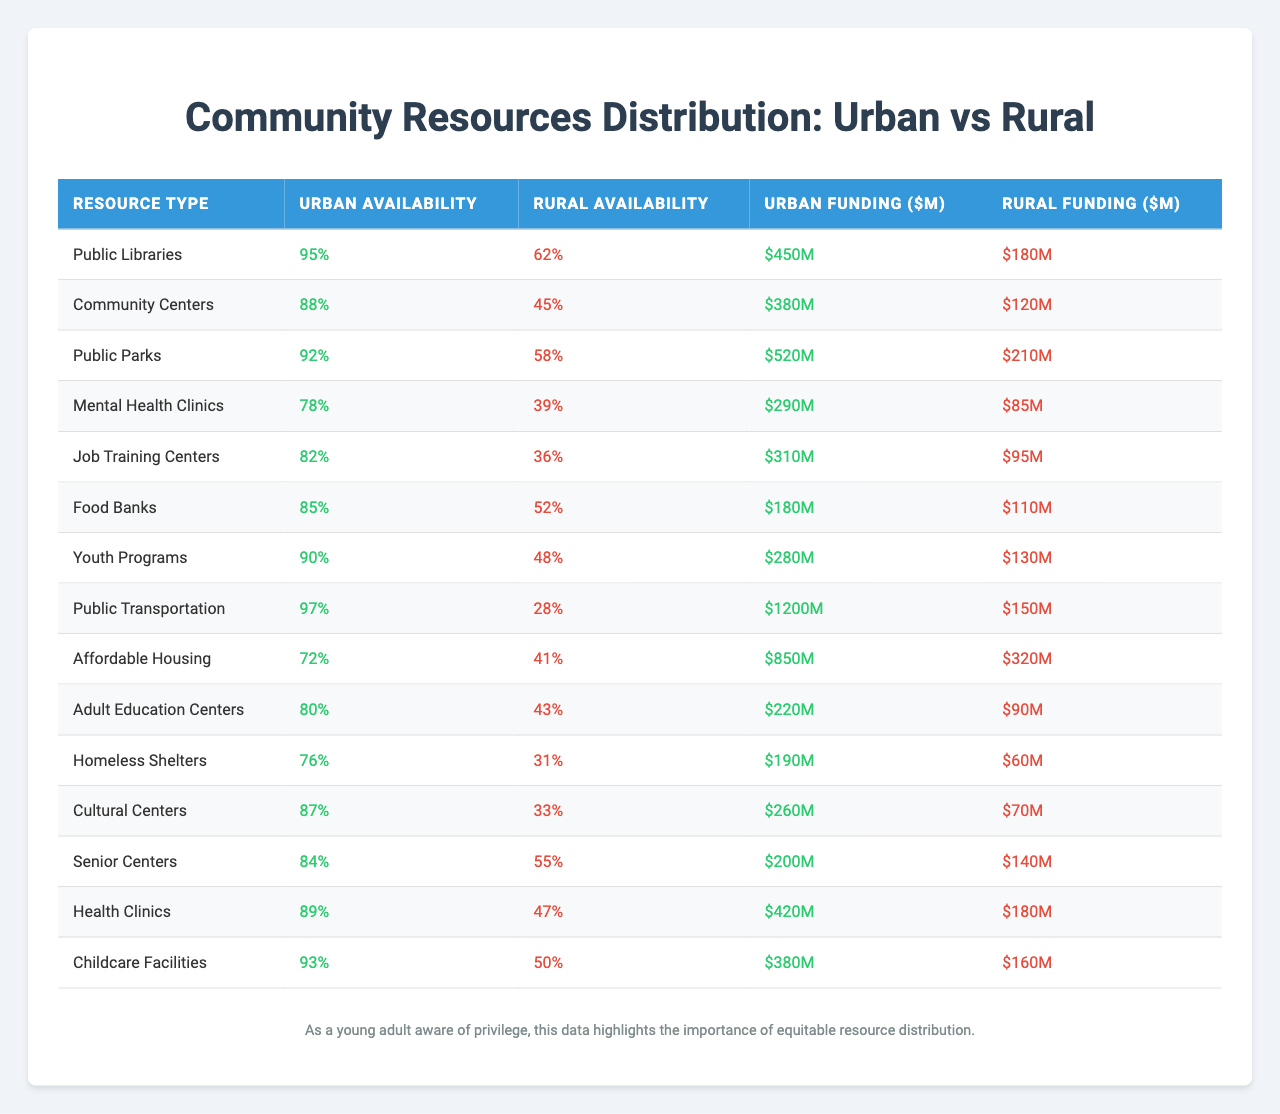What is the Urban Availability percentage for Public Libraries? The table shows that the Urban Availability for Public Libraries is listed as 95%.
Answer: 95% What is the total funding for Rural Food Banks and Mental Health Clinics? The funding for Rural Food Banks is $110M and for Mental Health Clinics is $85M. Adding these together: 110 + 85 = 195
Answer: $195M Are there more public parks in urban or rural areas? The table indicates 92% availability of public parks in urban areas compared to 58% in rural areas.
Answer: Urban areas Which resource type has the highest funding in urban areas? Looking at the table, Public Transportation has the highest funding at $1200M in urban areas.
Answer: Public Transportation What is the difference in Urban Availability between Community Centers and Affordable Housing? Community Centers have an Urban Availability of 88%, while Affordable Housing has 72%. The difference is 88 - 72 = 16%.
Answer: 16% Is the percentage of Food Banks available in rural areas higher than that of Job Training Centers? Food Banks have 52% availability in rural areas, while Job Training Centers have 36% availability. Since 52% > 36%, the statement is true.
Answer: Yes How does the funding for Senior Centers compare to that for Cultural Centers in urban areas? Senior Centers have $200M, while Cultural Centers have $260M in urban funding. So, Cultural Centers have $60M more than Senior Centers.
Answer: $60M What is the average Urban Availability percentage across all resource types listed? Summing the Urban Availability percentages: (95 + 88 + 92 + 78 + 82 + 85 + 90 + 97 + 72 + 80 + 76 + 87 + 84 + 89 + 93) = 1286. There are 15 resource types, so the average is 1286 / 15 = 85.73%.
Answer: 85.73% Which resource has the lowest Urban Funding while maintaining a moderate Urban Availability? The resource with the lowest Urban Funding is Job Training Centers at $310M and has an Urban Availability of 82%. This indicates a moderate availability with relatively low funding.
Answer: Job Training Centers What is the total difference in Rural Funding between the three highest and three lowest resource types? The three highest funding amounts are Public Transportation ($150M), Affordable Housing ($320M), and Food Banks ($110M), totaling 150 + 320 + 110 = 580M. The three lowest are Homeless Shelters ($60M), Cultural Centers ($70M), and Job Training Centers ($95M), totaling 60 + 70 + 95 = 225M. The difference is 580 - 225 = 355M.
Answer: $355M 